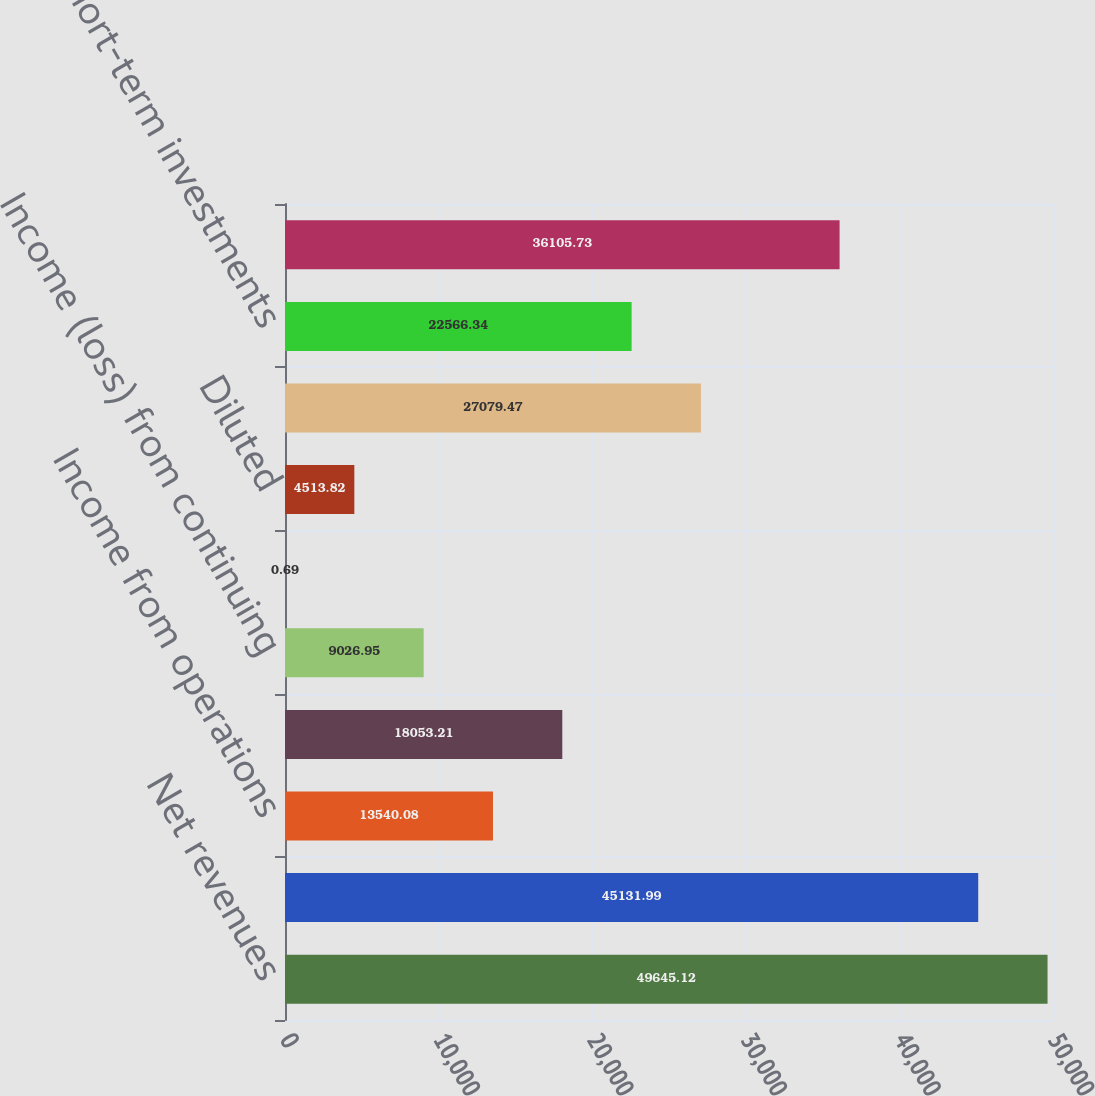Convert chart to OTSL. <chart><loc_0><loc_0><loc_500><loc_500><bar_chart><fcel>Net revenues<fcel>Gross profit<fcel>Income from operations<fcel>Income from continuing<fcel>Income (loss) from continuing<fcel>Basic<fcel>Diluted<fcel>Cash and cash equivalents<fcel>Short-term investments<fcel>Long-term investments<nl><fcel>49645.1<fcel>45132<fcel>13540.1<fcel>18053.2<fcel>9026.95<fcel>0.69<fcel>4513.82<fcel>27079.5<fcel>22566.3<fcel>36105.7<nl></chart> 